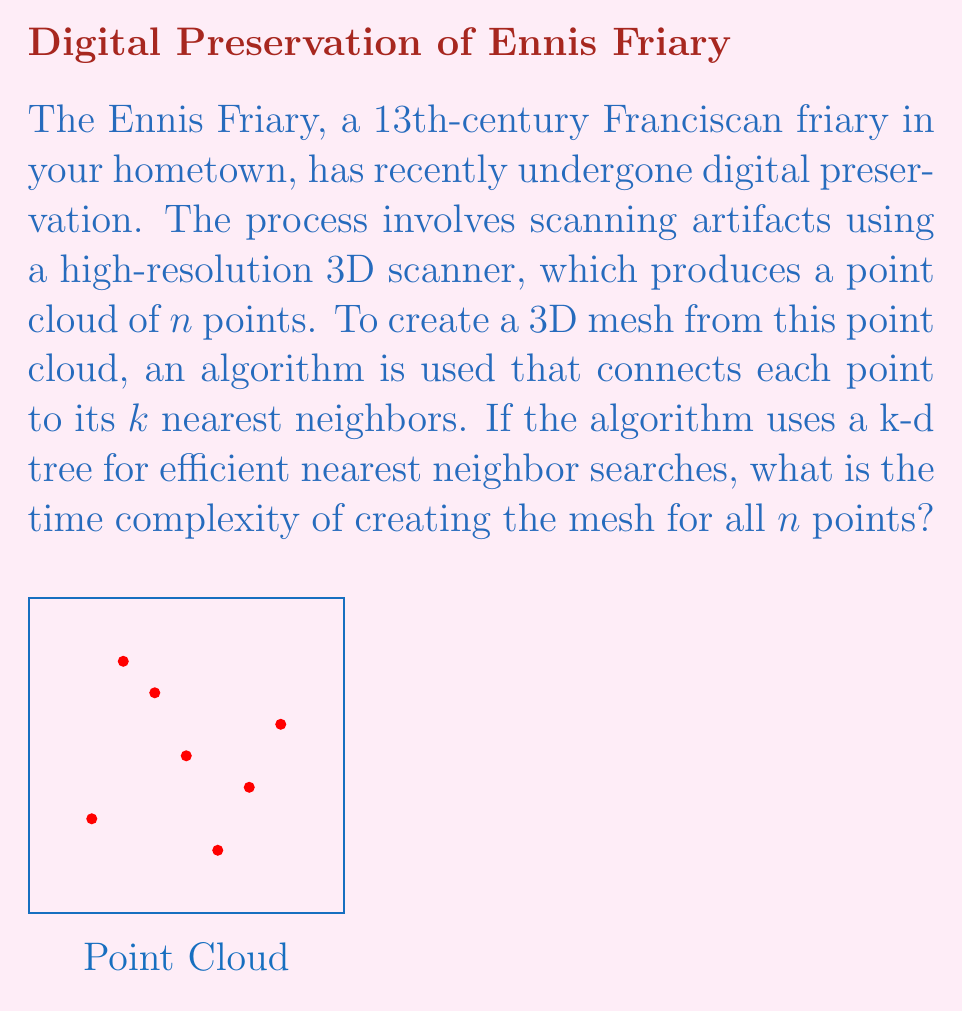Show me your answer to this math problem. Let's break this down step-by-step:

1) First, we need to construct the k-d tree from the $n$ points. The time complexity of building a k-d tree is $O(n \log n)$.

2) After constructing the k-d tree, for each of the $n$ points, we need to find its $k$ nearest neighbors.

3) A single nearest neighbor query in a k-d tree takes $O(\log n)$ time on average.

4) However, we're not just finding one nearest neighbor, but $k$ nearest neighbors. The time complexity for finding $k$ nearest neighbors is $O(k \log n)$.

5) We need to do this for all $n$ points, so the total time for finding nearest neighbors is $O(nk \log n)$.

6) After finding the neighbors, we need to connect each point to its $k$ nearest neighbors. This operation takes $O(k)$ time for each point, or $O(nk)$ time total.

7) The overall time complexity is the sum of these operations:
   
   $T(n) = O(n \log n) + O(nk \log n) + O(nk)$

8) Since $k$ is typically much smaller than $n$, we can simplify this to:
   
   $T(n) = O(nk \log n)$

This is because $O(n \log n)$ is dominated by $O(nk \log n)$ when $k > 1$, and $O(nk)$ is dominated by $O(nk \log n)$ for large $n$.
Answer: $O(nk \log n)$ 